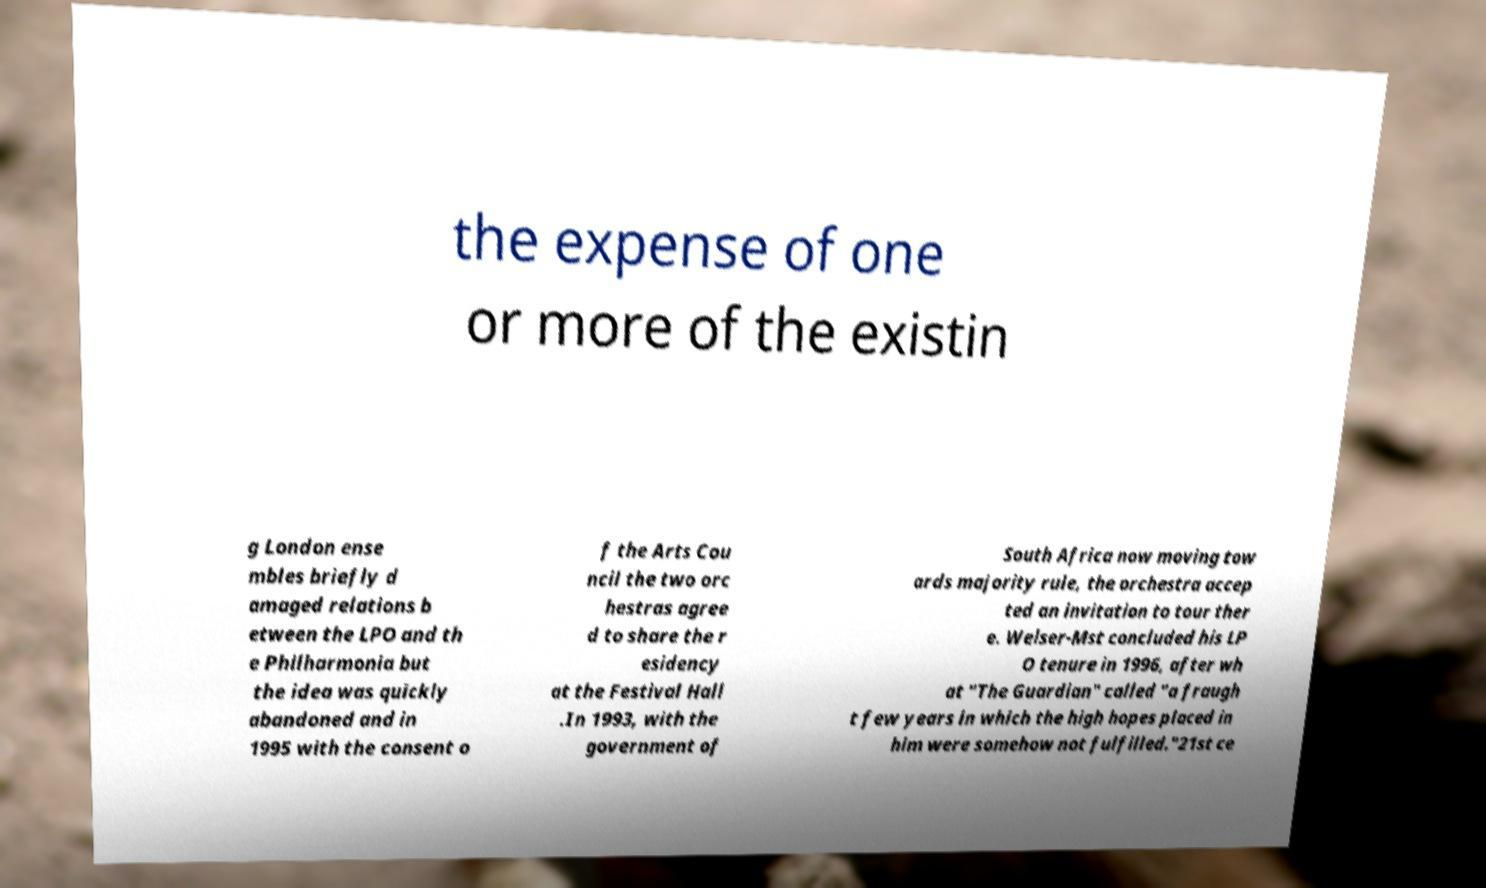There's text embedded in this image that I need extracted. Can you transcribe it verbatim? the expense of one or more of the existin g London ense mbles briefly d amaged relations b etween the LPO and th e Philharmonia but the idea was quickly abandoned and in 1995 with the consent o f the Arts Cou ncil the two orc hestras agree d to share the r esidency at the Festival Hall .In 1993, with the government of South Africa now moving tow ards majority rule, the orchestra accep ted an invitation to tour ther e. Welser-Mst concluded his LP O tenure in 1996, after wh at "The Guardian" called "a fraugh t few years in which the high hopes placed in him were somehow not fulfilled."21st ce 